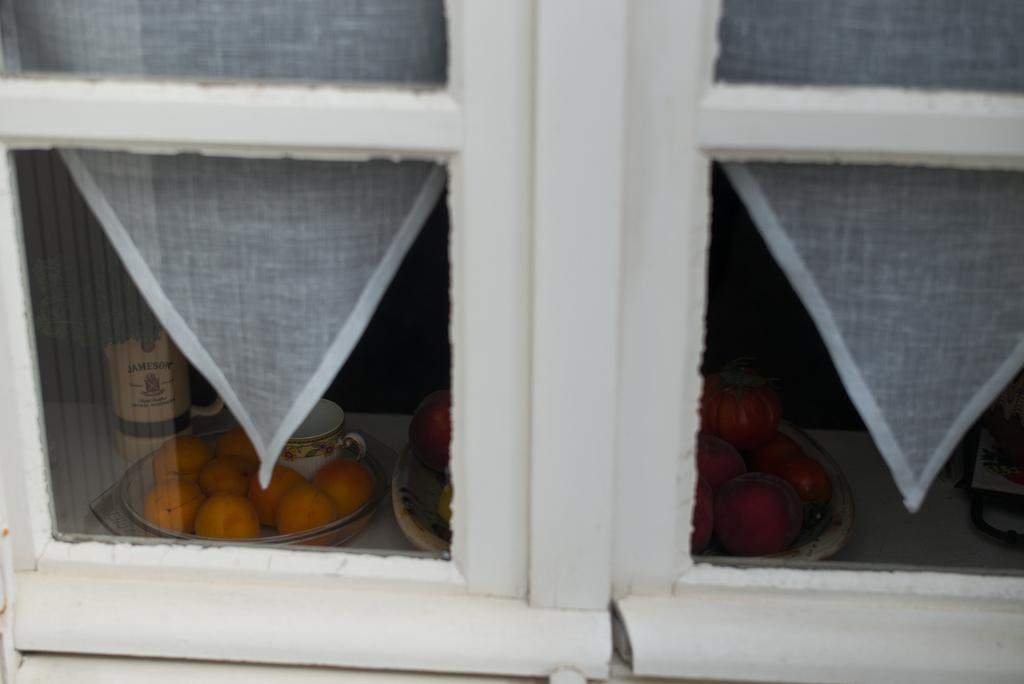What can be seen in the image through the window? Plates with fruits and cups are visible through the window. What is the primary purpose of the window in the image? The window provides a view of the objects outside, such as the plates with fruits and cups. Can you describe the object on the white surface in the image? Unfortunately, the provided facts do not give enough information to describe the object on the white surface. How many horses are visible through the window in the image? There are no horses visible through the window in the image. What type of tree can be seen growing near the window in the image? There is no tree present in the image. 